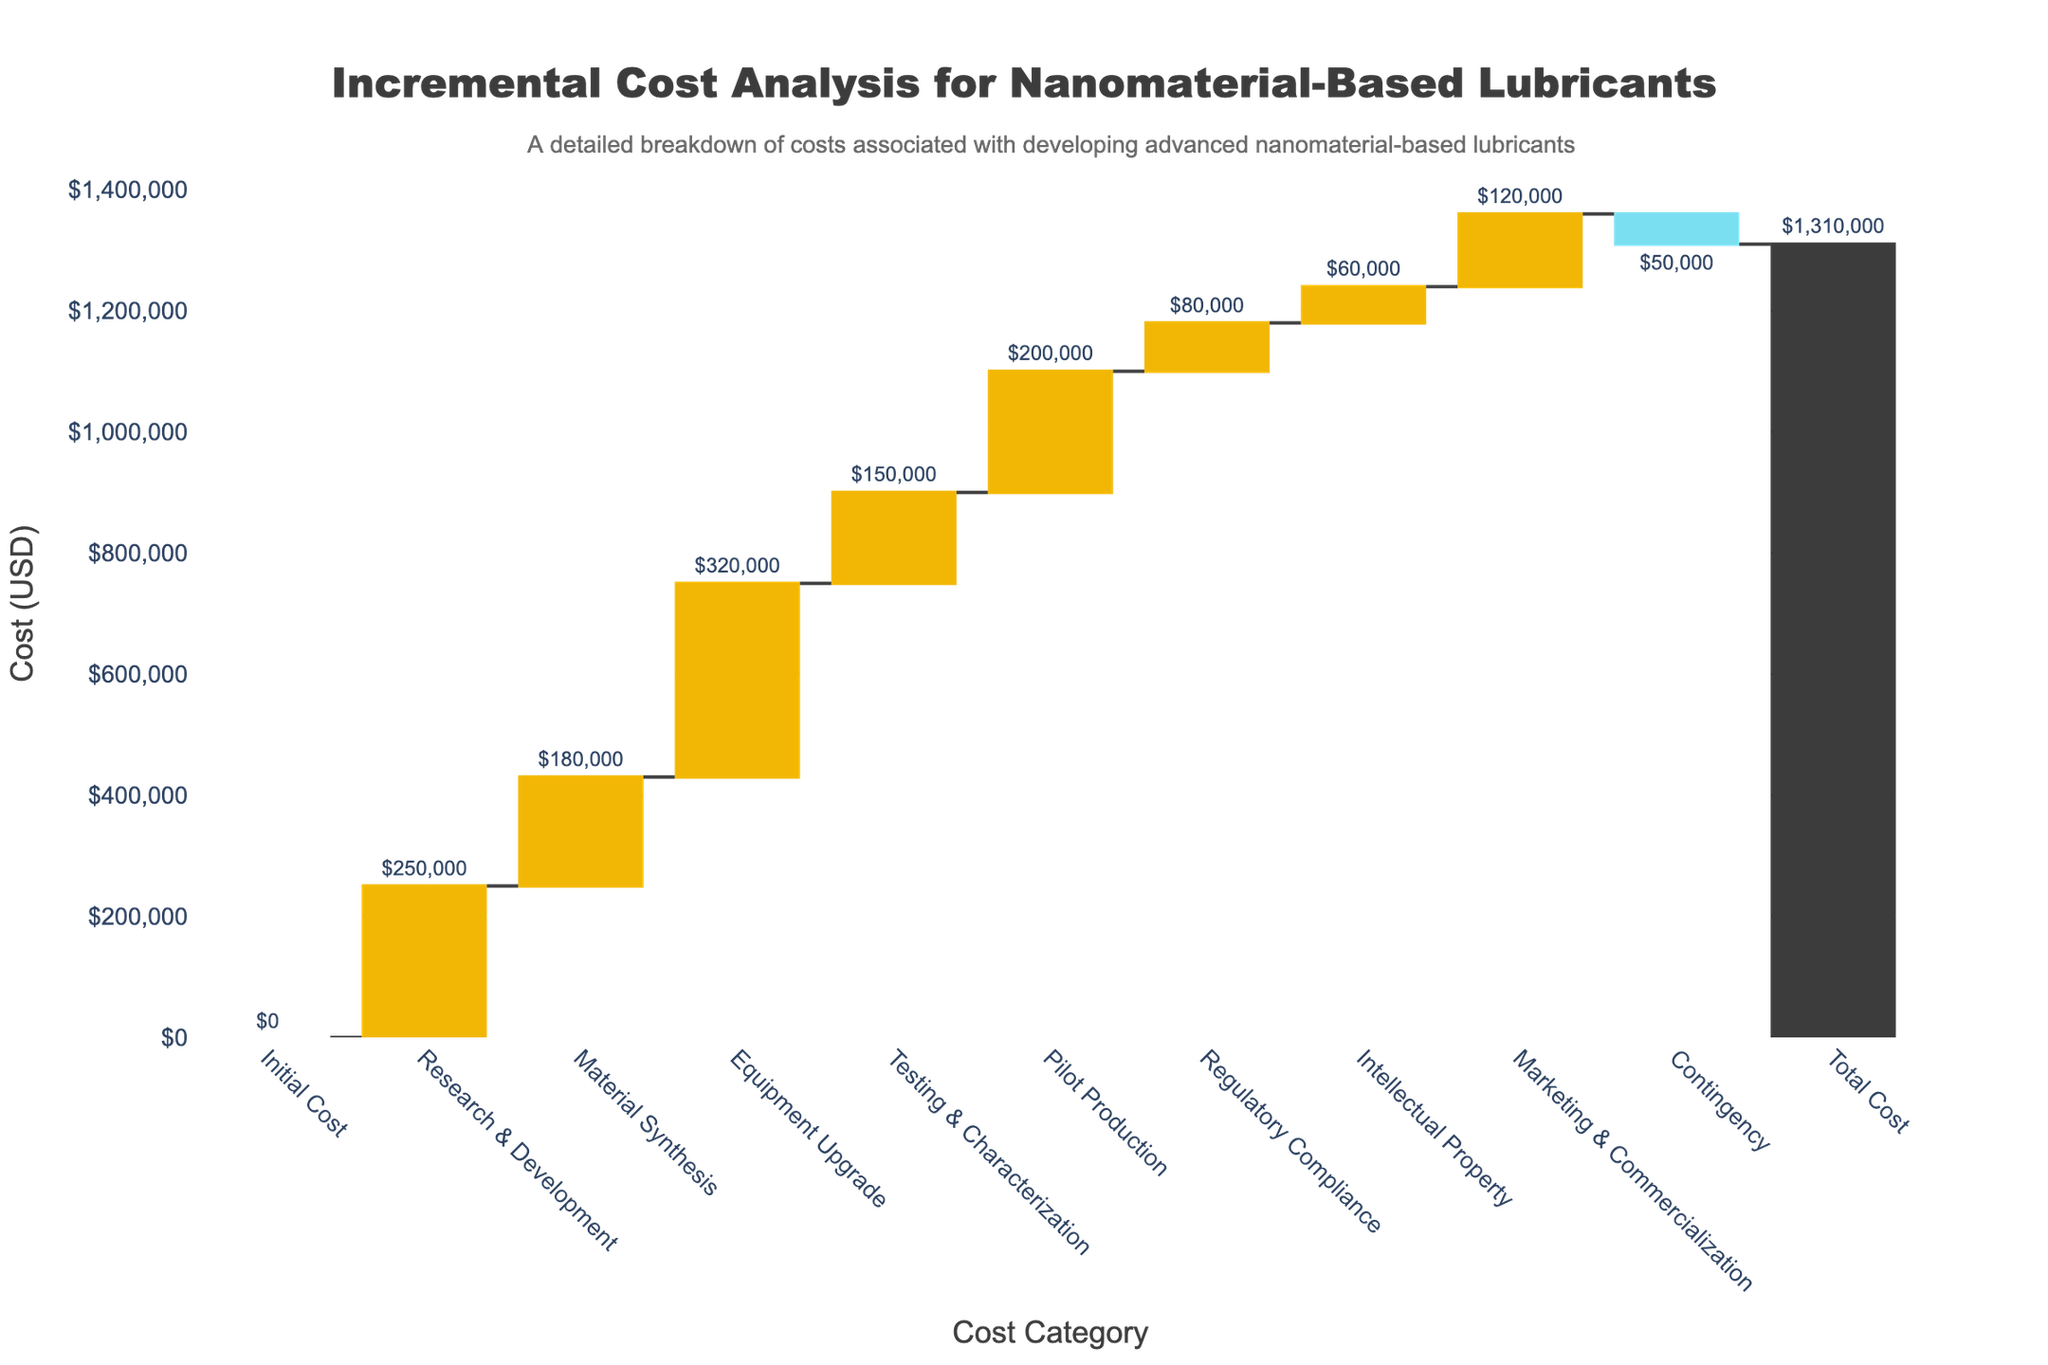What is the total cost for developing advanced nanomaterial-based lubricants according to the chart? The total cost is shown at the end of the waterfall chart under the "Total Cost" category. The value is provided in the figure with a text annotation.
Answer: $1,310,000 What is the highest individual cost category presented in the chart? To find the highest individual cost, look at the bars and their corresponding values. The "Equipment Upgrade" category has the highest value.
Answer: Equipment Upgrade: $320,000 Which cost category contributes the least to the overall cost (excluding the contingency)? Excluding the contingency, the smallest positive value bar corresponds to the "Intellectual Property" category with a value of $60,000.
Answer: Intellectual Property: $60,000 What is the net effect of the "Contingency" category on the total cost? The "Contingency" category has a negative value, indicating it reduces the total cost. The bar drops by $50,000.
Answer: -$50,000 How much does the "Material Synthesis" cost compared to the "Testing & Characterization" cost? To compare, look at the values for both categories. "Material Synthesis" costs $180,000 whereas "Testing & Characterization" costs $150,000. Material synthesis is $30,000 higher.
Answer: $30,000 How does the "Pilot Production" cost compare relative to the sum of "Material Synthesis" and "Testing & Characterization"? First, add the costs of "Material Synthesis" ($180,000) and "Testing & Characterization" ($150,000), which totals $330,000. Compare this with the "Pilot Production" cost of $200,000.
Answer: $200,000 is $130,000 less than $330,000 If you exclude "Marketing & Commercialization", what would the new total cost be? Exclude the cost of "Marketing & Commercialization" ($120,000) from the total cost ($1,310,000). The new total would be $1,310,000 - $120,000 = $1,190,000.
Answer: $1,190,000 What is the combined cost of "Testing & Characterization" and "Regulatory Compliance"? Add the values of both categories: "Testing & Characterization" ($150,000) and "Regulatory Compliance" ($80,000). The combined cost is $150,000 + $80,000 = $230,000.
Answer: $230,000 